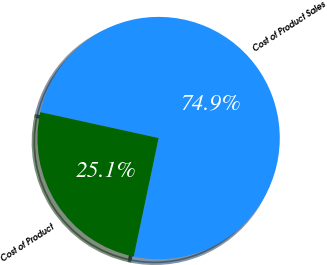Convert chart to OTSL. <chart><loc_0><loc_0><loc_500><loc_500><pie_chart><fcel>Cost of Product Sales<fcel>Cost of Product<nl><fcel>74.86%<fcel>25.14%<nl></chart> 